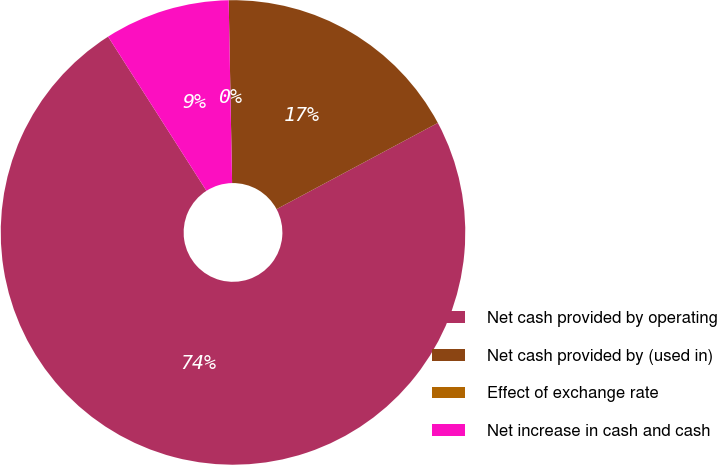<chart> <loc_0><loc_0><loc_500><loc_500><pie_chart><fcel>Net cash provided by operating<fcel>Net cash provided by (used in)<fcel>Effect of exchange rate<fcel>Net increase in cash and cash<nl><fcel>73.78%<fcel>17.48%<fcel>0.0%<fcel>8.74%<nl></chart> 